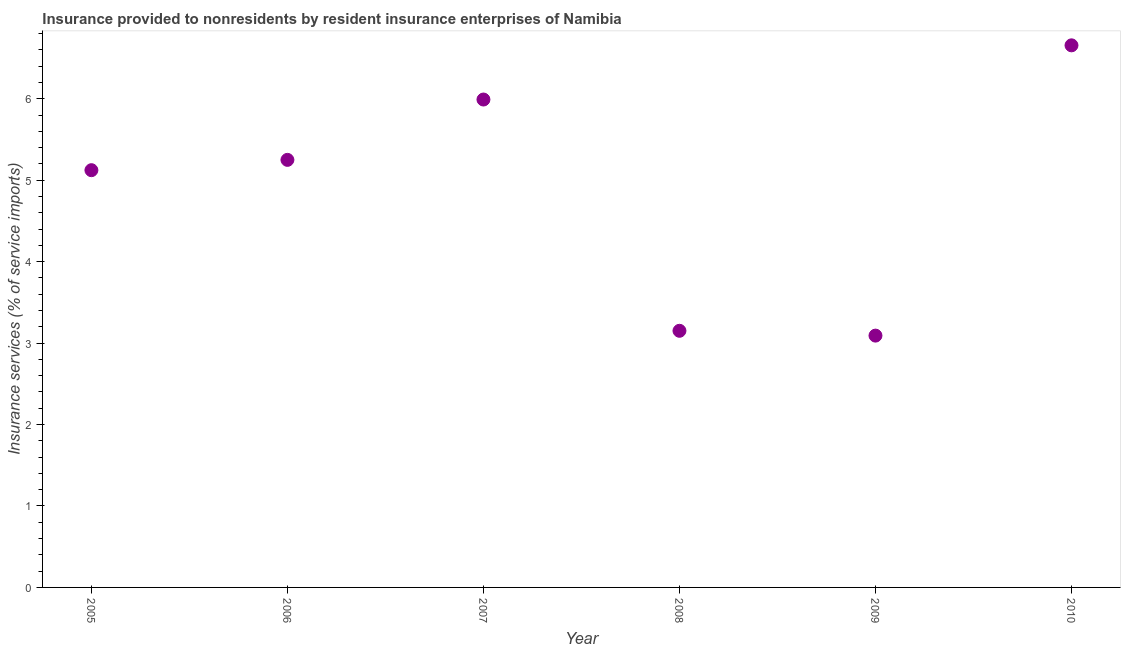What is the insurance and financial services in 2007?
Offer a very short reply. 5.99. Across all years, what is the maximum insurance and financial services?
Your answer should be compact. 6.66. Across all years, what is the minimum insurance and financial services?
Your answer should be compact. 3.09. In which year was the insurance and financial services maximum?
Offer a very short reply. 2010. What is the sum of the insurance and financial services?
Your answer should be very brief. 29.26. What is the difference between the insurance and financial services in 2007 and 2010?
Your answer should be compact. -0.67. What is the average insurance and financial services per year?
Give a very brief answer. 4.88. What is the median insurance and financial services?
Give a very brief answer. 5.19. What is the ratio of the insurance and financial services in 2007 to that in 2010?
Keep it short and to the point. 0.9. Is the insurance and financial services in 2008 less than that in 2009?
Offer a terse response. No. What is the difference between the highest and the second highest insurance and financial services?
Your response must be concise. 0.67. What is the difference between the highest and the lowest insurance and financial services?
Your answer should be compact. 3.56. In how many years, is the insurance and financial services greater than the average insurance and financial services taken over all years?
Your answer should be very brief. 4. Does the insurance and financial services monotonically increase over the years?
Give a very brief answer. No. How many dotlines are there?
Offer a terse response. 1. How many years are there in the graph?
Offer a very short reply. 6. Are the values on the major ticks of Y-axis written in scientific E-notation?
Offer a terse response. No. What is the title of the graph?
Make the answer very short. Insurance provided to nonresidents by resident insurance enterprises of Namibia. What is the label or title of the X-axis?
Your response must be concise. Year. What is the label or title of the Y-axis?
Offer a very short reply. Insurance services (% of service imports). What is the Insurance services (% of service imports) in 2005?
Make the answer very short. 5.12. What is the Insurance services (% of service imports) in 2006?
Ensure brevity in your answer.  5.25. What is the Insurance services (% of service imports) in 2007?
Provide a succinct answer. 5.99. What is the Insurance services (% of service imports) in 2008?
Offer a very short reply. 3.15. What is the Insurance services (% of service imports) in 2009?
Your answer should be very brief. 3.09. What is the Insurance services (% of service imports) in 2010?
Keep it short and to the point. 6.66. What is the difference between the Insurance services (% of service imports) in 2005 and 2006?
Ensure brevity in your answer.  -0.13. What is the difference between the Insurance services (% of service imports) in 2005 and 2007?
Ensure brevity in your answer.  -0.87. What is the difference between the Insurance services (% of service imports) in 2005 and 2008?
Provide a succinct answer. 1.97. What is the difference between the Insurance services (% of service imports) in 2005 and 2009?
Provide a succinct answer. 2.03. What is the difference between the Insurance services (% of service imports) in 2005 and 2010?
Make the answer very short. -1.53. What is the difference between the Insurance services (% of service imports) in 2006 and 2007?
Provide a succinct answer. -0.74. What is the difference between the Insurance services (% of service imports) in 2006 and 2008?
Provide a short and direct response. 2.1. What is the difference between the Insurance services (% of service imports) in 2006 and 2009?
Keep it short and to the point. 2.16. What is the difference between the Insurance services (% of service imports) in 2006 and 2010?
Keep it short and to the point. -1.41. What is the difference between the Insurance services (% of service imports) in 2007 and 2008?
Provide a succinct answer. 2.84. What is the difference between the Insurance services (% of service imports) in 2007 and 2009?
Keep it short and to the point. 2.9. What is the difference between the Insurance services (% of service imports) in 2007 and 2010?
Offer a terse response. -0.67. What is the difference between the Insurance services (% of service imports) in 2008 and 2009?
Provide a succinct answer. 0.06. What is the difference between the Insurance services (% of service imports) in 2008 and 2010?
Your answer should be very brief. -3.51. What is the difference between the Insurance services (% of service imports) in 2009 and 2010?
Keep it short and to the point. -3.56. What is the ratio of the Insurance services (% of service imports) in 2005 to that in 2006?
Your answer should be very brief. 0.98. What is the ratio of the Insurance services (% of service imports) in 2005 to that in 2007?
Ensure brevity in your answer.  0.85. What is the ratio of the Insurance services (% of service imports) in 2005 to that in 2008?
Offer a very short reply. 1.63. What is the ratio of the Insurance services (% of service imports) in 2005 to that in 2009?
Offer a very short reply. 1.66. What is the ratio of the Insurance services (% of service imports) in 2005 to that in 2010?
Make the answer very short. 0.77. What is the ratio of the Insurance services (% of service imports) in 2006 to that in 2007?
Give a very brief answer. 0.88. What is the ratio of the Insurance services (% of service imports) in 2006 to that in 2008?
Your response must be concise. 1.67. What is the ratio of the Insurance services (% of service imports) in 2006 to that in 2009?
Offer a terse response. 1.7. What is the ratio of the Insurance services (% of service imports) in 2006 to that in 2010?
Ensure brevity in your answer.  0.79. What is the ratio of the Insurance services (% of service imports) in 2007 to that in 2008?
Ensure brevity in your answer.  1.9. What is the ratio of the Insurance services (% of service imports) in 2007 to that in 2009?
Your answer should be very brief. 1.94. What is the ratio of the Insurance services (% of service imports) in 2008 to that in 2009?
Provide a short and direct response. 1.02. What is the ratio of the Insurance services (% of service imports) in 2008 to that in 2010?
Make the answer very short. 0.47. What is the ratio of the Insurance services (% of service imports) in 2009 to that in 2010?
Your answer should be very brief. 0.47. 